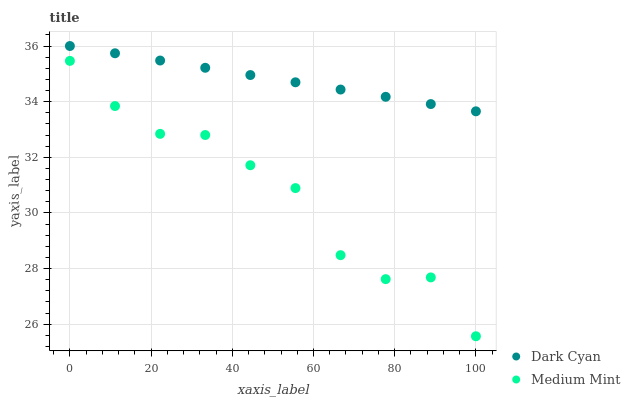Does Medium Mint have the minimum area under the curve?
Answer yes or no. Yes. Does Dark Cyan have the maximum area under the curve?
Answer yes or no. Yes. Does Medium Mint have the maximum area under the curve?
Answer yes or no. No. Is Dark Cyan the smoothest?
Answer yes or no. Yes. Is Medium Mint the roughest?
Answer yes or no. Yes. Is Medium Mint the smoothest?
Answer yes or no. No. Does Medium Mint have the lowest value?
Answer yes or no. Yes. Does Dark Cyan have the highest value?
Answer yes or no. Yes. Does Medium Mint have the highest value?
Answer yes or no. No. Is Medium Mint less than Dark Cyan?
Answer yes or no. Yes. Is Dark Cyan greater than Medium Mint?
Answer yes or no. Yes. Does Medium Mint intersect Dark Cyan?
Answer yes or no. No. 